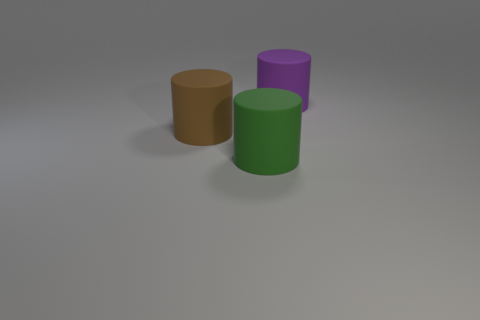Add 3 big cylinders. How many objects exist? 6 Subtract all brown cylinders. How many cylinders are left? 2 Subtract all big purple rubber cylinders. How many cylinders are left? 2 Subtract 0 yellow cylinders. How many objects are left? 3 Subtract 3 cylinders. How many cylinders are left? 0 Subtract all cyan cylinders. Subtract all gray cubes. How many cylinders are left? 3 Subtract all green cubes. How many blue cylinders are left? 0 Subtract all purple cylinders. Subtract all tiny green objects. How many objects are left? 2 Add 2 green cylinders. How many green cylinders are left? 3 Add 1 big green cylinders. How many big green cylinders exist? 2 